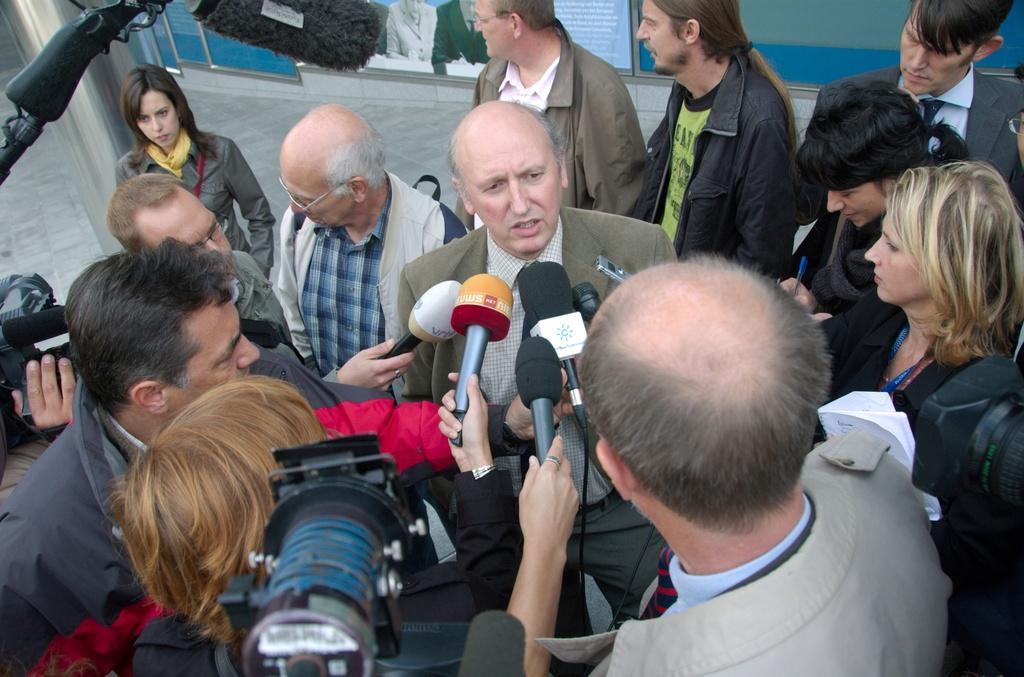In one or two sentences, can you explain what this image depicts? In this image there is a person. In front of him there are a few people holding the mics and cameras. Behind the person there are a few other people standing. On the left side of the image there is a pole. In the background of the image there are boards with pictures and text on it. 